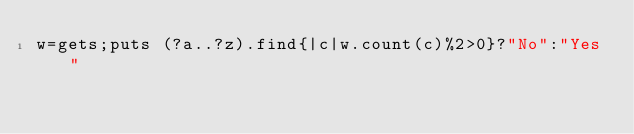Convert code to text. <code><loc_0><loc_0><loc_500><loc_500><_Ruby_>w=gets;puts (?a..?z).find{|c|w.count(c)%2>0}?"No":"Yes"</code> 